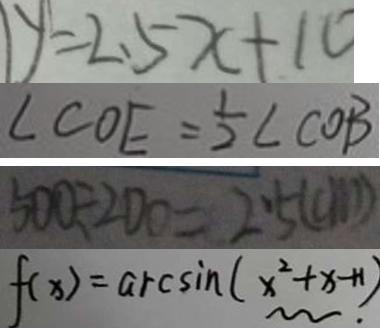Convert formula to latex. <formula><loc_0><loc_0><loc_500><loc_500>y = 2 . 5 x + 1 0 
 \angle C O E = \frac { 1 } { 2 } \angle C O B 
 5 0 0 \div 2 0 0 = 2 . 5 ( c m ) 
 f ( x ) = \arcsin ( x ^ { 2 } + x + 1 ) .</formula> 